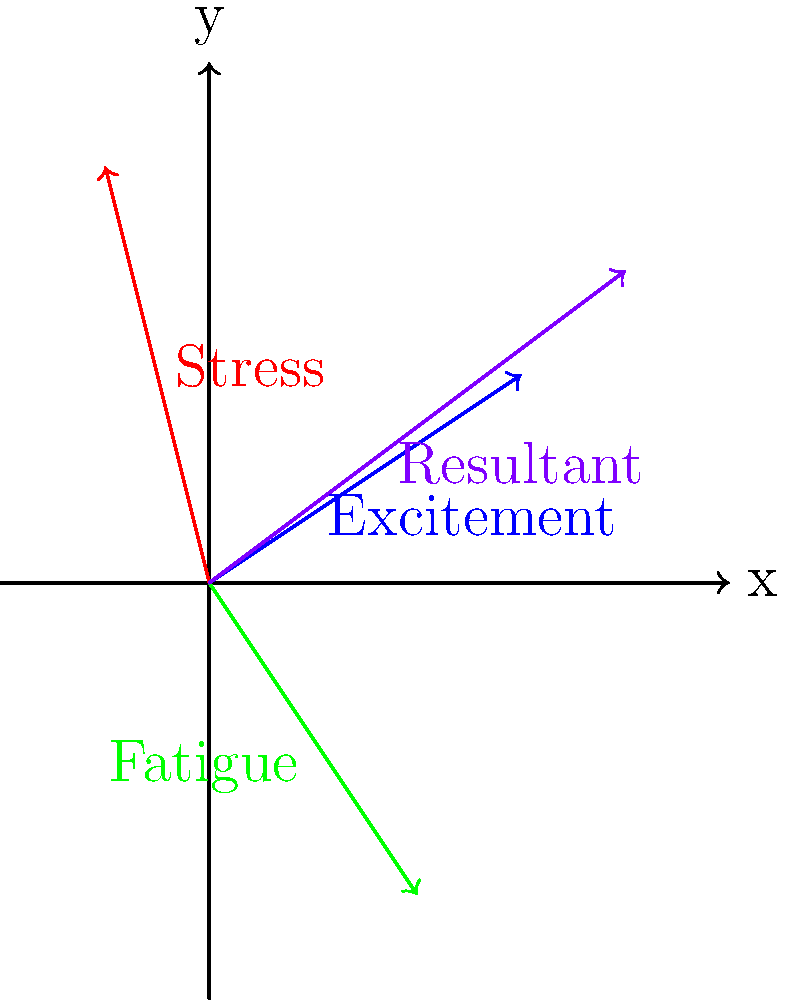In your research on mood-influencing factors and consumer behavior, you've identified three key emotional vectors: Excitement $(3, 2)$, Stress $(-1, 4)$, and Fatigue $(2, -3)$. Calculate the resultant vector that represents the overall mood state. How might this resultant mood vector potentially impact consumer purchasing behavior? To determine the resultant vector of multiple mood-influencing factors, we need to use vector addition. Here's a step-by-step approach:

1) Identify the given vectors:
   Excitement: $\vec{v_1} = (3, 2)$
   Stress: $\vec{v_2} = (-1, 4)$
   Fatigue: $\vec{v_3} = (2, -3)$

2) Add the x-components:
   $x_{resultant} = 3 + (-1) + 2 = 4$

3) Add the y-components:
   $y_{resultant} = 2 + 4 + (-3) = 3$

4) The resultant vector is therefore:
   $\vec{R} = (4, 3)$

5) To interpret this result in the context of consumer behavior:
   - The positive x-component (4) suggests a tendency towards approach behavior, which could lead to increased purchasing.
   - The positive y-component (3) indicates an elevated arousal state, which might result in more impulsive buying decisions.

6) The magnitude of the resultant vector can be calculated using the Pythagorean theorem:
   $|\vec{R}| = \sqrt{4^2 + 3^2} = 5$

This magnitude suggests a moderately strong overall mood state, which could significantly influence consumer behavior.
Answer: $\vec{R} = (4, 3)$; moderate-strong mood state potentially leading to approach behavior and impulsive purchasing 